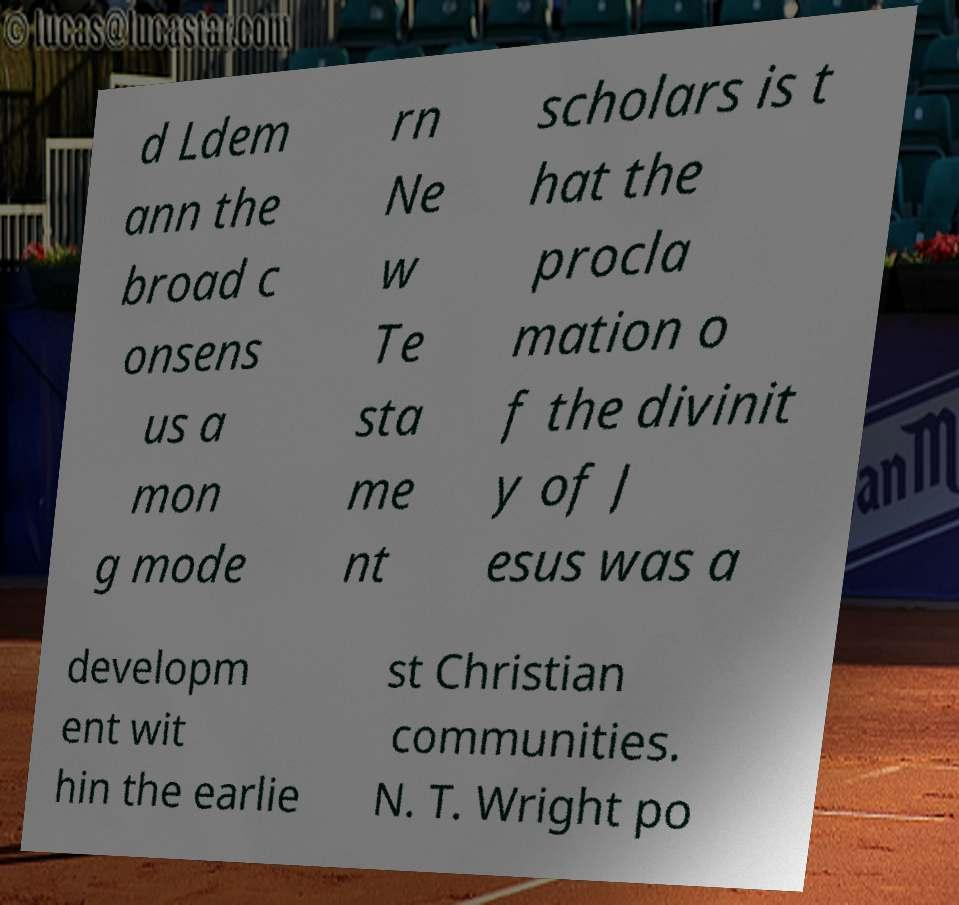Could you extract and type out the text from this image? d Ldem ann the broad c onsens us a mon g mode rn Ne w Te sta me nt scholars is t hat the procla mation o f the divinit y of J esus was a developm ent wit hin the earlie st Christian communities. N. T. Wright po 